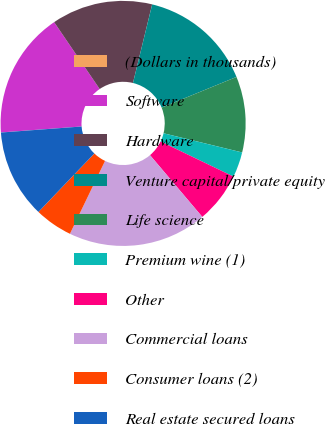<chart> <loc_0><loc_0><loc_500><loc_500><pie_chart><fcel>(Dollars in thousands)<fcel>Software<fcel>Hardware<fcel>Venture capital/private equity<fcel>Life science<fcel>Premium wine (1)<fcel>Other<fcel>Commercial loans<fcel>Consumer loans (2)<fcel>Real estate secured loans<nl><fcel>0.01%<fcel>16.66%<fcel>13.33%<fcel>15.0%<fcel>10.0%<fcel>3.34%<fcel>6.67%<fcel>18.33%<fcel>5.0%<fcel>11.67%<nl></chart> 